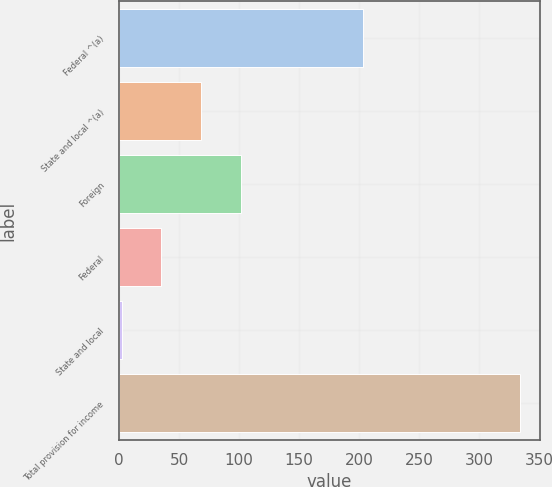Convert chart to OTSL. <chart><loc_0><loc_0><loc_500><loc_500><bar_chart><fcel>Federal ^(a)<fcel>State and local ^(a)<fcel>Foreign<fcel>Federal<fcel>State and local<fcel>Total provision for income<nl><fcel>203<fcel>68.4<fcel>101.6<fcel>35.2<fcel>2<fcel>334<nl></chart> 